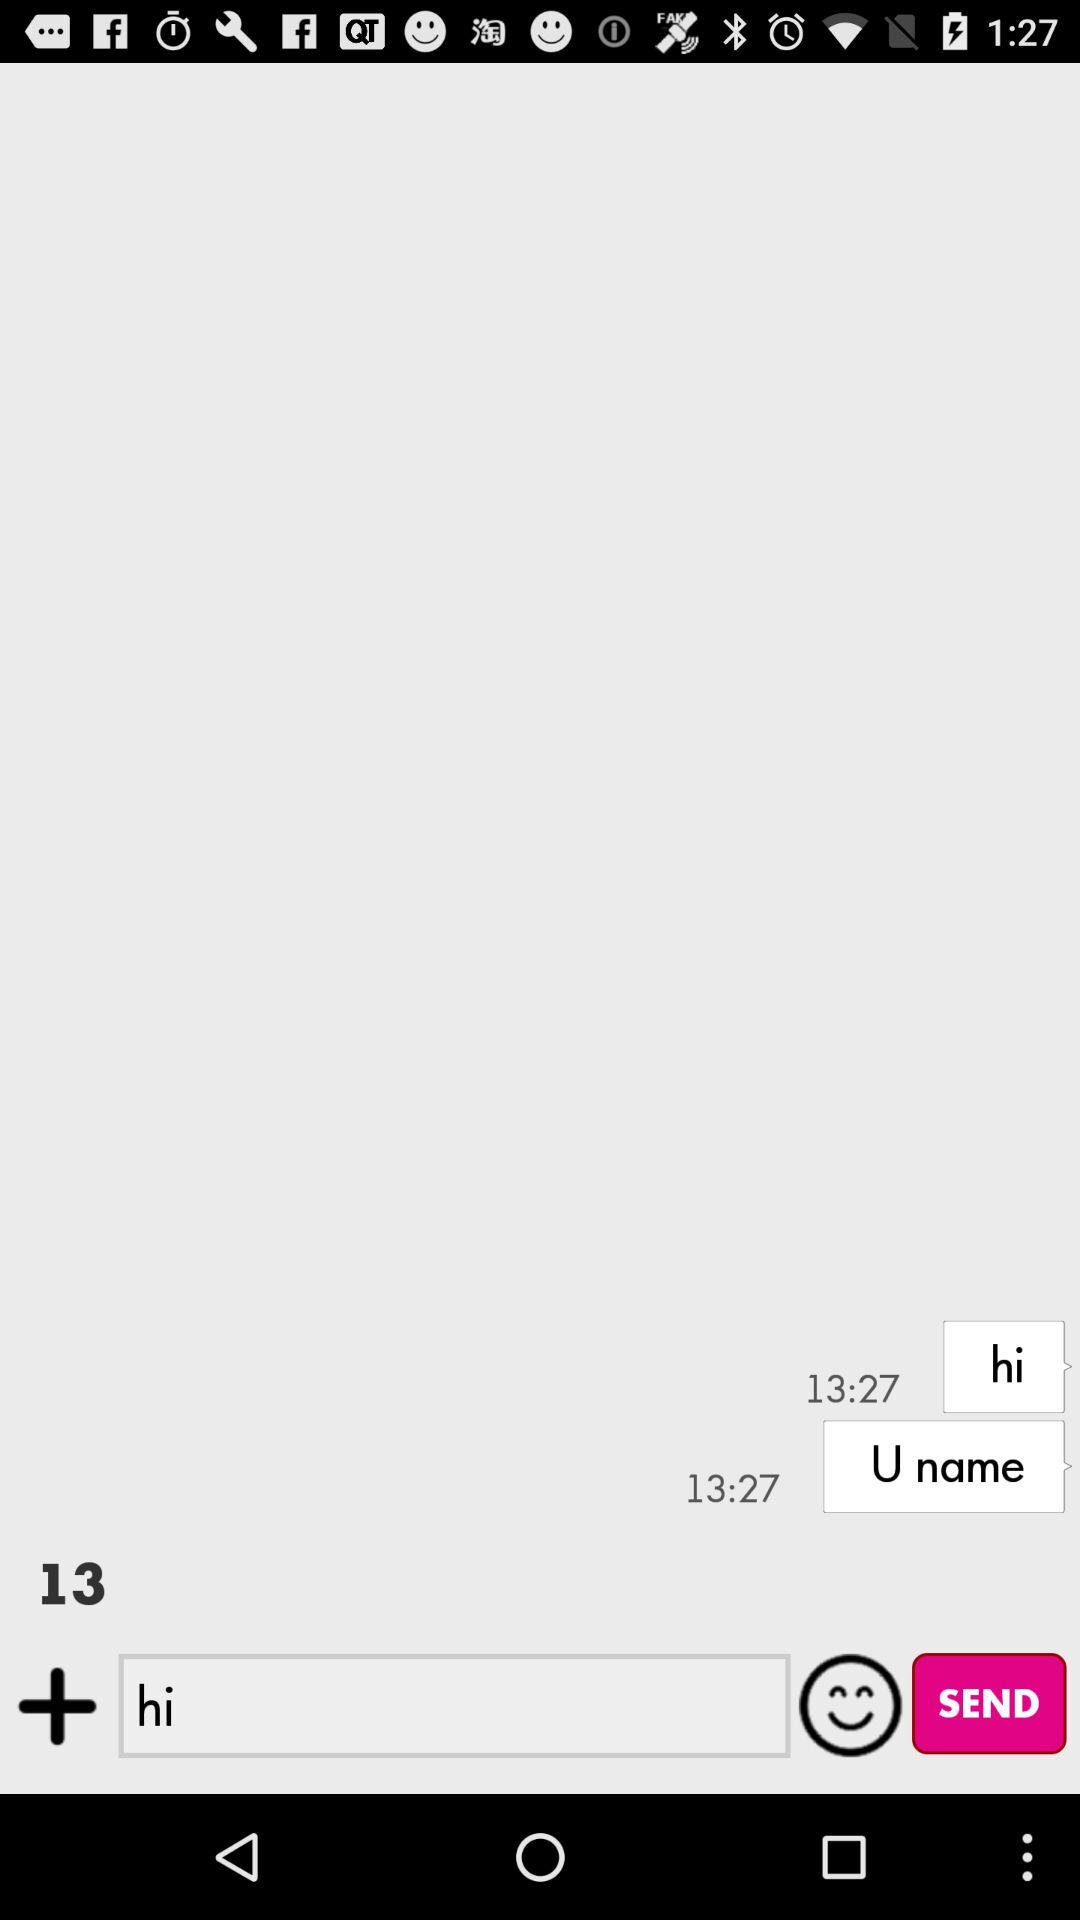What is the message delivery time? The message delivery time is 13:27. 